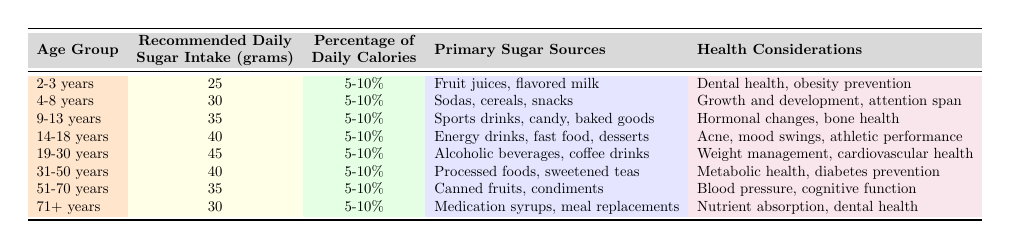What is the recommended daily sugar intake for a 9-13 year old? From the table, under the age group "9-13 years," the recommended daily sugar intake is listed as 35 grams.
Answer: 35 grams Which age group has the highest recommended daily sugar intake? The table indicates that the age group "19-30 years" has the highest recommended daily sugar intake at 45 grams.
Answer: 19-30 years Is the recommended daily sugar intake for children (2-13 years) more than that for adults (19-50 years)? By comparing the values, children aged 2-13 years have intakes of 25, 30, and 35 grams, while adults aged 19-50 years have intakes of 45 and 40 grams respectively. Therefore, children do not exceed adult recommendations.
Answer: No What is the percentage of daily calories that the 14-18 years age group should derive from sugar? According to the table, the percentage of daily calories from sugar for the 14-18 years age group is stated as 5-10%.
Answer: 5-10% What is the average recommended daily sugar intake for those aged 31 to 70 years? The recommended daily sugar intakes for the age groups 31-50 years (40 grams), 51-70 years (35 grams), and 71+ years (30 grams) are added together: 40 + 35 + 30 = 105 grams. There are 3 age groups, so the average is 105 grams / 3 = 35 grams.
Answer: 35 grams Which primary sugar sources are recommended for individuals aged 4-8 years? The table lists "Sodas, cereals, snacks" as the primary sugar sources for the 4-8 years age group.
Answer: Sodas, cereals, snacks Are the health considerations for the 14-18 years age group focused on physical or mental health? The health considerations for this age group include "Acne, mood swings, athletic performance," indicating both physical (athletic performance) and mental (mood swings) health concerns. This implies that health considerations for this group cover both aspects.
Answer: Both physical and mental health What is the recommended daily sugar intake for seniors (71+ years) compared to that for toddlers (2-3 years)? The table shows a recommended intake of 30 grams for those aged 71+ years and 25 grams for toddlers aged 2-3 years. Therefore, seniors have a higher recommended intake than toddlers.
Answer: Seniors have a higher intake If a 19-30 year old consumes 45 grams of sugar daily, what would be their daily percentage of calories from sugar if their total calorie intake is 2,000 calories? To find the percentage, use the formula: (grams of sugar / total calories) * 100. Here, (45 / 2000) * 100 = 2.25%. This percentage is below the recommended range of 5-10%.
Answer: 2.25% Which age group has the same recommended daily sugar intake as those aged 51-70 years? The age group 31-50 years also has a recommended daily sugar intake of 40 grams, which makes it the same as those aged 51-70 years, who have a recommended intake of 35 grams.
Answer: None; adults 31-50 have 40 grams, others differ 